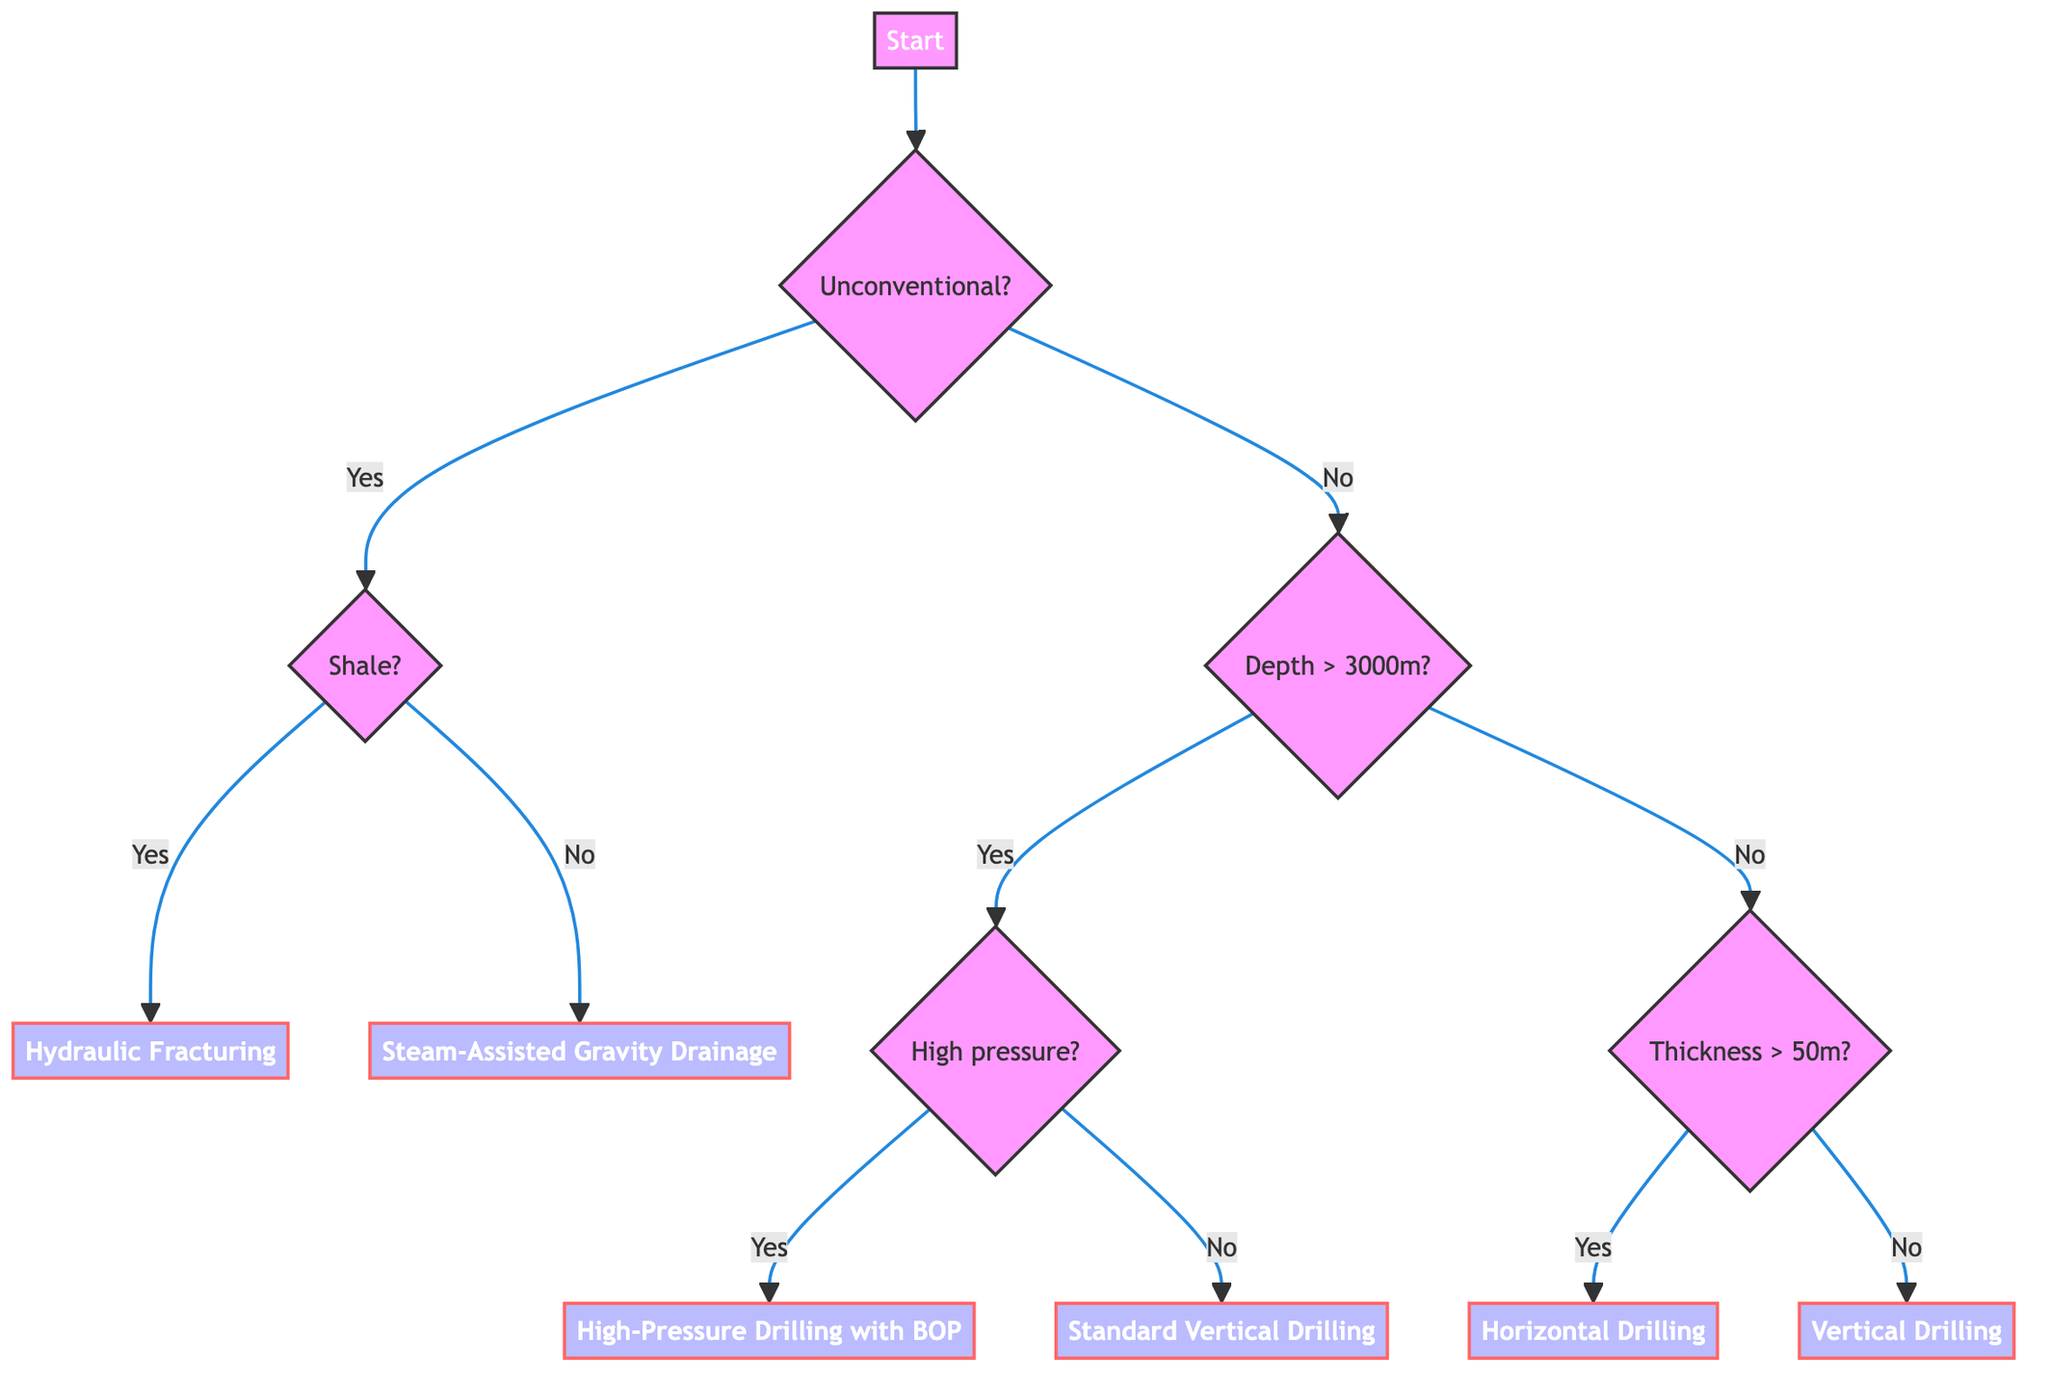What is the first question in the decision tree? The diagram starts with the question "Is the reservoir unconventional (e.g., shale, tar sands)?" which is placed at the root node.
Answer: Is the reservoir unconventional (e.g., shale, tar sands)? What method is chosen if the reservoir is a shale reservoir? If the reservoir is determined to be unconventional and specifically classified as a shale reservoir, the method chosen is "Hydraulic Fracturing (Fracking)." This can be derived from the 'yes' pathway following the question about whether it is a shale reservoir.
Answer: Hydraulic Fracturing (Fracking) How many methods are listed in the decision tree? The diagram lists a total of five different methods. These methods are identified in the lower sections of the tree, branching out from various conditions. Counting each distinct method gives a total of five.
Answer: 5 What is the method for a shallow reservoir with thickness greater than 50 meters? For a shallow reservoir where the thickness is greater than 50 meters, the decision path leads to the method called "Horizontal Drilling." This can be found by following the appropriate branches in the decision tree.
Answer: Horizontal Drilling If the reservoir depth is less than 3000 meters and thickness is less than or equal to 50 meters, what is the method used? In this case, if the reservoir depth is less than 3000 meters (leading to the shallow reservoir pathway) and the thickness is less than or equal to 50 meters, we end up at "Vertical Drilling." This involves reasoning through the nodes that represent these conditions.
Answer: Vertical Drilling What is the output method if the reservoir has high pressure and a depth greater than 3000 meters? Following the decision path for a reservoir that is deep (depth greater than 3000 meters) and has high pressure leads to the method "High-Pressure Drilling with Blowout Preventer." This method is reached by navigating through the respective questions about depth and pressure.
Answer: High-Pressure Drilling with Blowout Preventer What condition must be met for Standard Vertical Drilling to be the chosen method? Standard Vertical Drilling is selected when the reservoir is conventional, the depth is greater than 3000 meters, and the reservoir pressure is low. Following this specific set of conditions through the decision tree confirms this method's selection.
Answer: Low pressure How does one reach the method of Steam-Assisted Gravity Drainage? To reach Steam-Assisted Gravity Drainage, one must first determine that the reservoir is unconventional and specifically a tar sands reservoir. The flowchart sequence begins with identifying the unconventional status, then confirming it's not shale leads to this method.
Answer: Steam-Assisted Gravity Drainage 